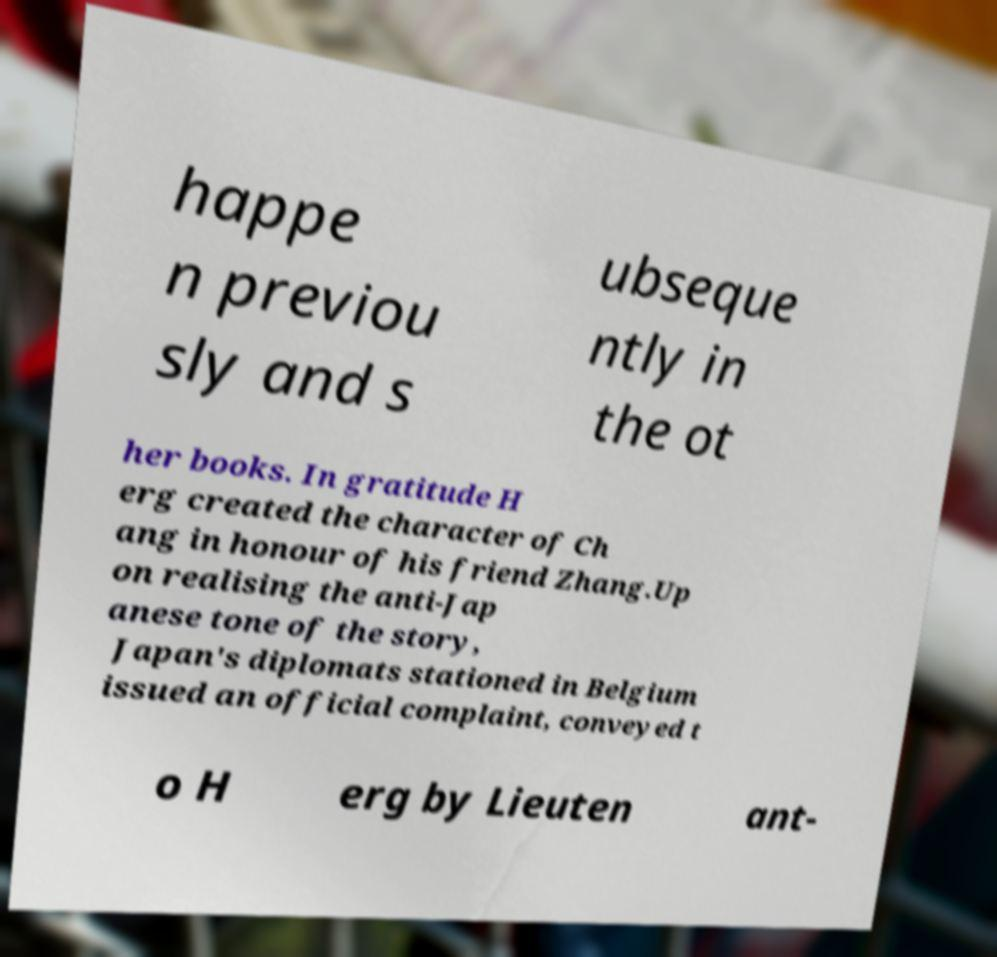Please read and relay the text visible in this image. What does it say? happe n previou sly and s ubseque ntly in the ot her books. In gratitude H erg created the character of Ch ang in honour of his friend Zhang.Up on realising the anti-Jap anese tone of the story, Japan's diplomats stationed in Belgium issued an official complaint, conveyed t o H erg by Lieuten ant- 